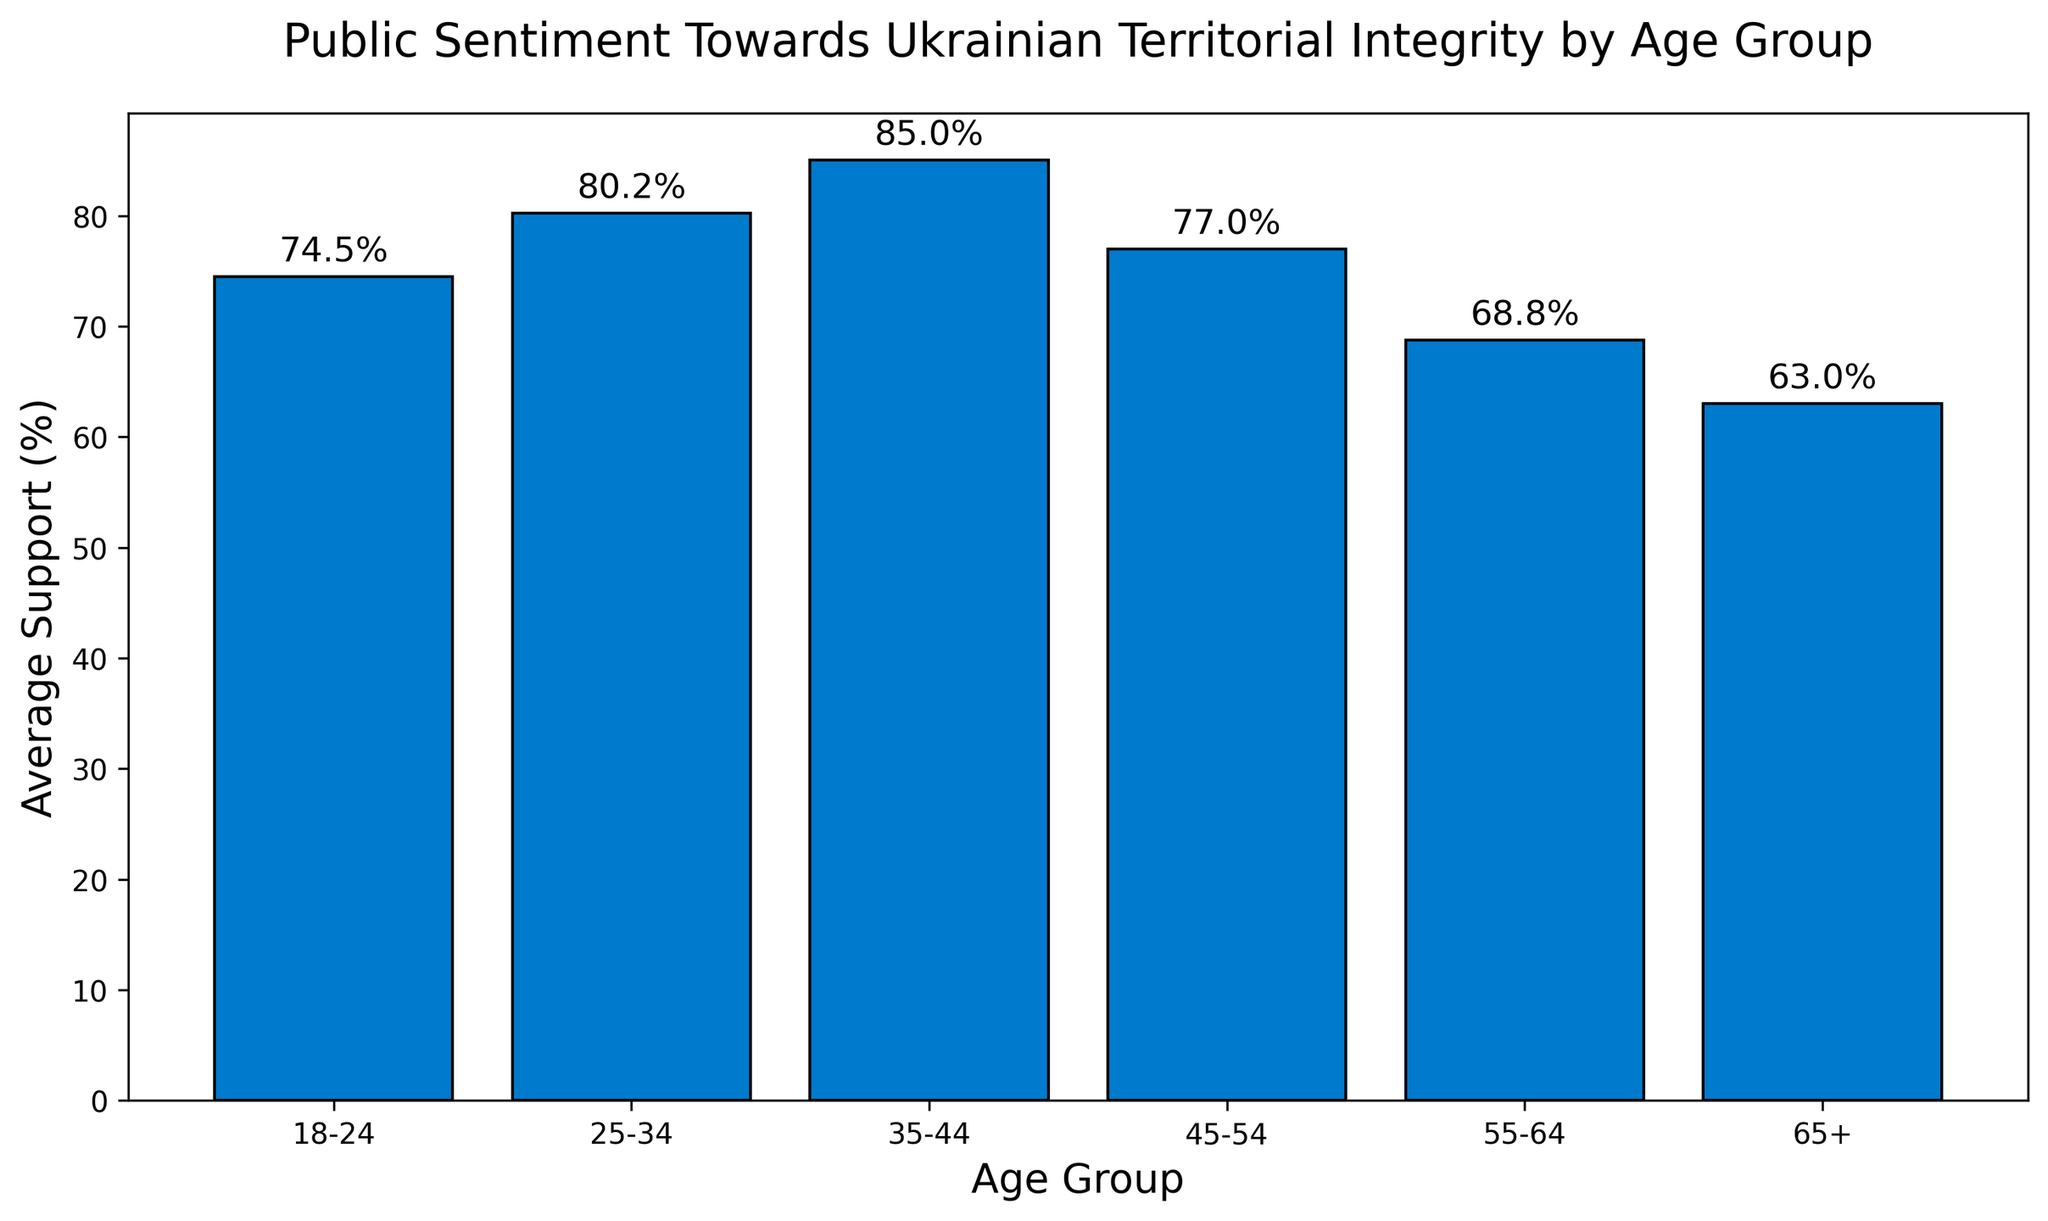What's the average support for territorial integrity in the 35-44 age group? Calculate the average of the values in the 35-44 age group: (85 + 88 + 84 + 83) / 4 = 340 / 4 = 85
Answer: 85 Which age group shows the highest average support towards Ukrainian territorial integrity? Compare the average support across all age groups and identify the highest: 18-24: 74.5, 25-34: 80.25, 35-44: 85, 45-54: 77, 55-64: 68.75, 65+: 63
Answer: 35-44 How much higher is the average support among the 25-34 age group compared to the 65+ age group? Calculate the average support for both age groups and find the difference: 80.25 - 63 = 17.25
Answer: 17.25 What is the average support across all age groups combined? Calculate the average support of all recorded data points: (75 + 80 + 85 + 78 + 70 + 65 + 72 + 82 + 88 + 76 + 68 + 60 + 77 + 78 + 84 + 75 + 66 + 63 + 74 + 81 + 83 + 79 + 71 + 64) / 24 = 1746 / 24 = 72.75
Answer: 72.75 Which age group shows the lowest level of support for Ukrainian territorial integrity? Compare the average support across all age groups and identify the lowest: 18-24: 74.5, 25-34: 80.25, 35-44: 85, 45-54: 77, 55-64: 68.75, 65+: 63
Answer: 65+ How does the support in the 45-54 age group compare to the support in the 18-24 age group? Compare the average support for the 45-54 age group (77) with the 18-24 age group (74.5): 77 - 74.5 = 2.5
Answer: Higher by 2.5 Which age group has the greatest range in support towards territorial integrity? Calculate the range (max - min) for each age group: 18-24: 77 - 72 = 5, 25-34: 82 - 78 = 4, 35-44: 88 - 83 = 5, 45-54: 79 - 75 = 4, 55-64: 71 - 66 = 5, 65+: 65 - 60 = 5
Answer: Several groups have the same range of 5 What is the combined support of the age groups 25-34 and 45-54 averaged? Calculate the average support of both groups combined: (80.25 + 77) / 2 = 157.25 / 2 = 78.625
Answer: 78.625 How does the height of the bar for 55-64 compare to the height of the bar for 65+? The average support for 55-64 is 68.75, whereas for 65+ it is 63, making the bar for 55-64 taller by 5.75 units
Answer: 5.75 units taller By how much does the average support of the 18-24 group vary from the average overall support? Calculate the difference between the average support of the 18-24 group (74.5) and the overall average (72.75): 74.5 - 72.75 = 1.75
Answer: 1.75 